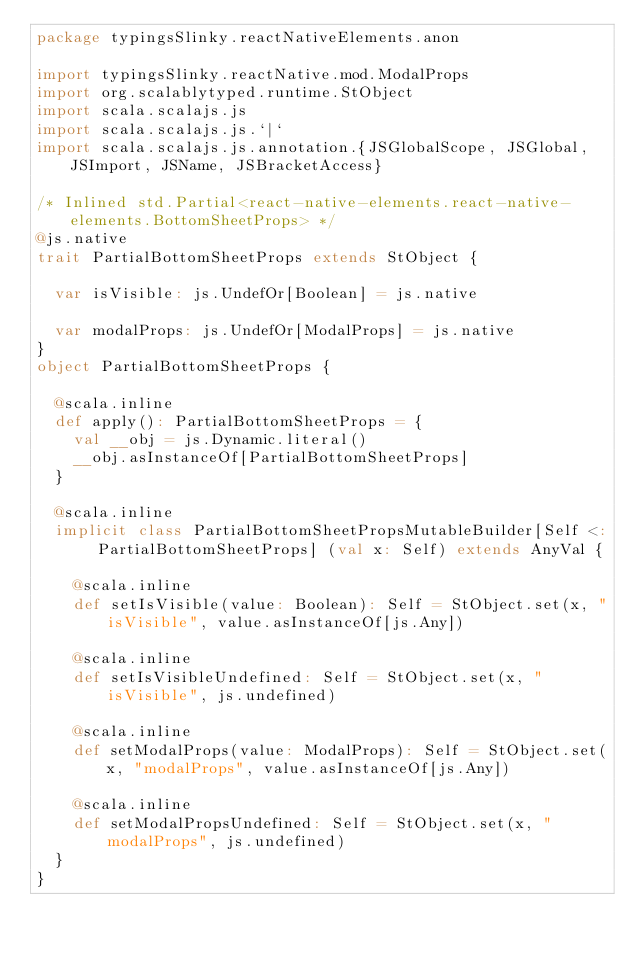<code> <loc_0><loc_0><loc_500><loc_500><_Scala_>package typingsSlinky.reactNativeElements.anon

import typingsSlinky.reactNative.mod.ModalProps
import org.scalablytyped.runtime.StObject
import scala.scalajs.js
import scala.scalajs.js.`|`
import scala.scalajs.js.annotation.{JSGlobalScope, JSGlobal, JSImport, JSName, JSBracketAccess}

/* Inlined std.Partial<react-native-elements.react-native-elements.BottomSheetProps> */
@js.native
trait PartialBottomSheetProps extends StObject {
  
  var isVisible: js.UndefOr[Boolean] = js.native
  
  var modalProps: js.UndefOr[ModalProps] = js.native
}
object PartialBottomSheetProps {
  
  @scala.inline
  def apply(): PartialBottomSheetProps = {
    val __obj = js.Dynamic.literal()
    __obj.asInstanceOf[PartialBottomSheetProps]
  }
  
  @scala.inline
  implicit class PartialBottomSheetPropsMutableBuilder[Self <: PartialBottomSheetProps] (val x: Self) extends AnyVal {
    
    @scala.inline
    def setIsVisible(value: Boolean): Self = StObject.set(x, "isVisible", value.asInstanceOf[js.Any])
    
    @scala.inline
    def setIsVisibleUndefined: Self = StObject.set(x, "isVisible", js.undefined)
    
    @scala.inline
    def setModalProps(value: ModalProps): Self = StObject.set(x, "modalProps", value.asInstanceOf[js.Any])
    
    @scala.inline
    def setModalPropsUndefined: Self = StObject.set(x, "modalProps", js.undefined)
  }
}
</code> 